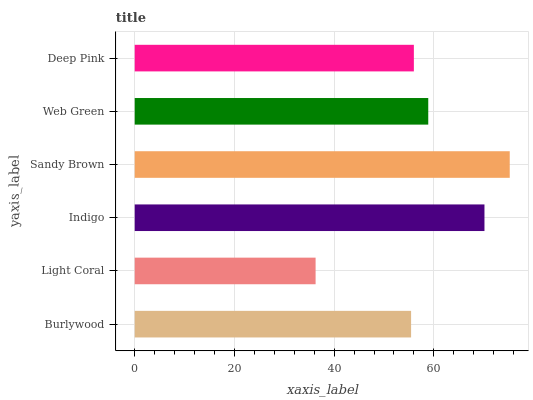Is Light Coral the minimum?
Answer yes or no. Yes. Is Sandy Brown the maximum?
Answer yes or no. Yes. Is Indigo the minimum?
Answer yes or no. No. Is Indigo the maximum?
Answer yes or no. No. Is Indigo greater than Light Coral?
Answer yes or no. Yes. Is Light Coral less than Indigo?
Answer yes or no. Yes. Is Light Coral greater than Indigo?
Answer yes or no. No. Is Indigo less than Light Coral?
Answer yes or no. No. Is Web Green the high median?
Answer yes or no. Yes. Is Deep Pink the low median?
Answer yes or no. Yes. Is Deep Pink the high median?
Answer yes or no. No. Is Web Green the low median?
Answer yes or no. No. 